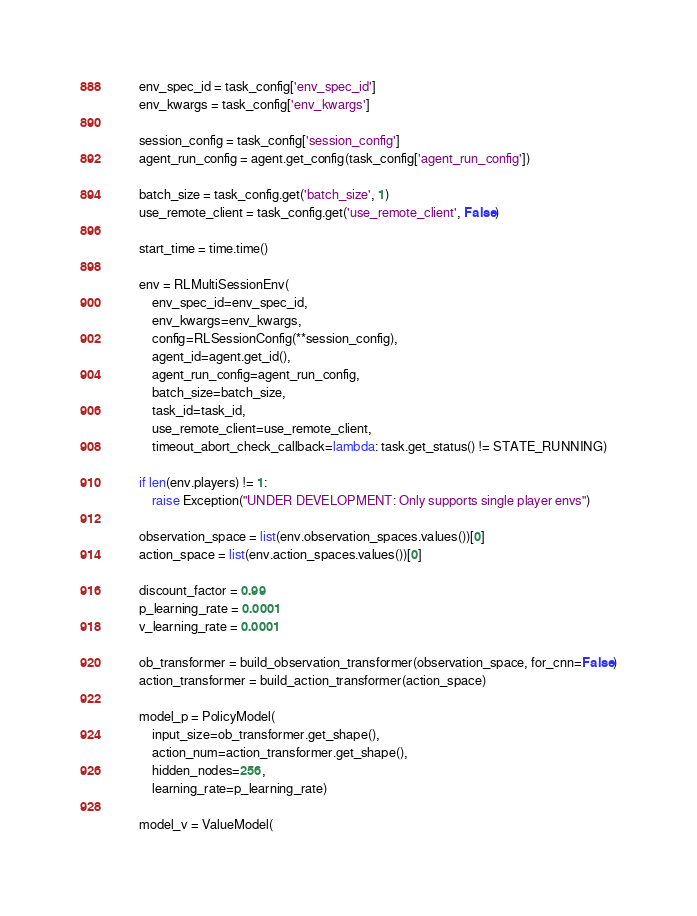<code> <loc_0><loc_0><loc_500><loc_500><_Python_>
        env_spec_id = task_config['env_spec_id']
        env_kwargs = task_config['env_kwargs']

        session_config = task_config['session_config']
        agent_run_config = agent.get_config(task_config['agent_run_config'])

        batch_size = task_config.get('batch_size', 1)
        use_remote_client = task_config.get('use_remote_client', False)

        start_time = time.time()

        env = RLMultiSessionEnv(
            env_spec_id=env_spec_id,
            env_kwargs=env_kwargs,
            config=RLSessionConfig(**session_config),
            agent_id=agent.get_id(),
            agent_run_config=agent_run_config,
            batch_size=batch_size,
            task_id=task_id,
            use_remote_client=use_remote_client,
            timeout_abort_check_callback=lambda: task.get_status() != STATE_RUNNING)

        if len(env.players) != 1:
            raise Exception("UNDER DEVELOPMENT: Only supports single player envs")

        observation_space = list(env.observation_spaces.values())[0]
        action_space = list(env.action_spaces.values())[0]

        discount_factor = 0.99
        p_learning_rate = 0.0001
        v_learning_rate = 0.0001

        ob_transformer = build_observation_transformer(observation_space, for_cnn=False)
        action_transformer = build_action_transformer(action_space)

        model_p = PolicyModel(
            input_size=ob_transformer.get_shape(),
            action_num=action_transformer.get_shape(),
            hidden_nodes=256,
            learning_rate=p_learning_rate)

        model_v = ValueModel(</code> 